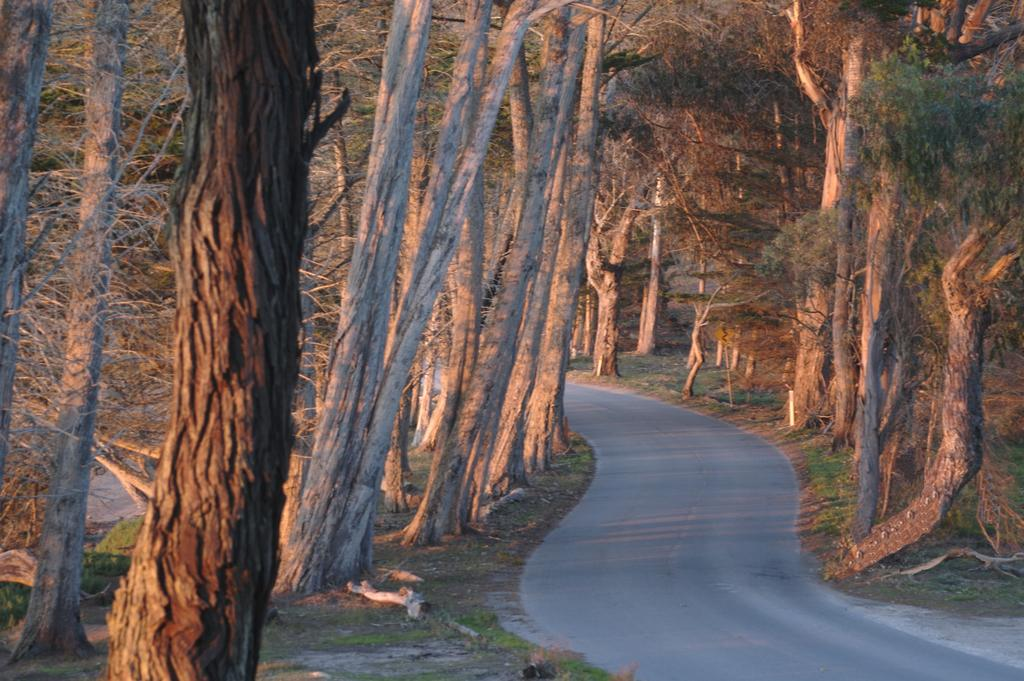What type of surface can be seen in the image? There is a road in the image. What type of vegetation is present in the image? Grass is present in the image. What can be seen on either side of the image? There are trees on either side of the image. How does the thumb affect the balance of the trees in the image? There is no thumb present in the image, and therefore it cannot affect the balance of the trees. 